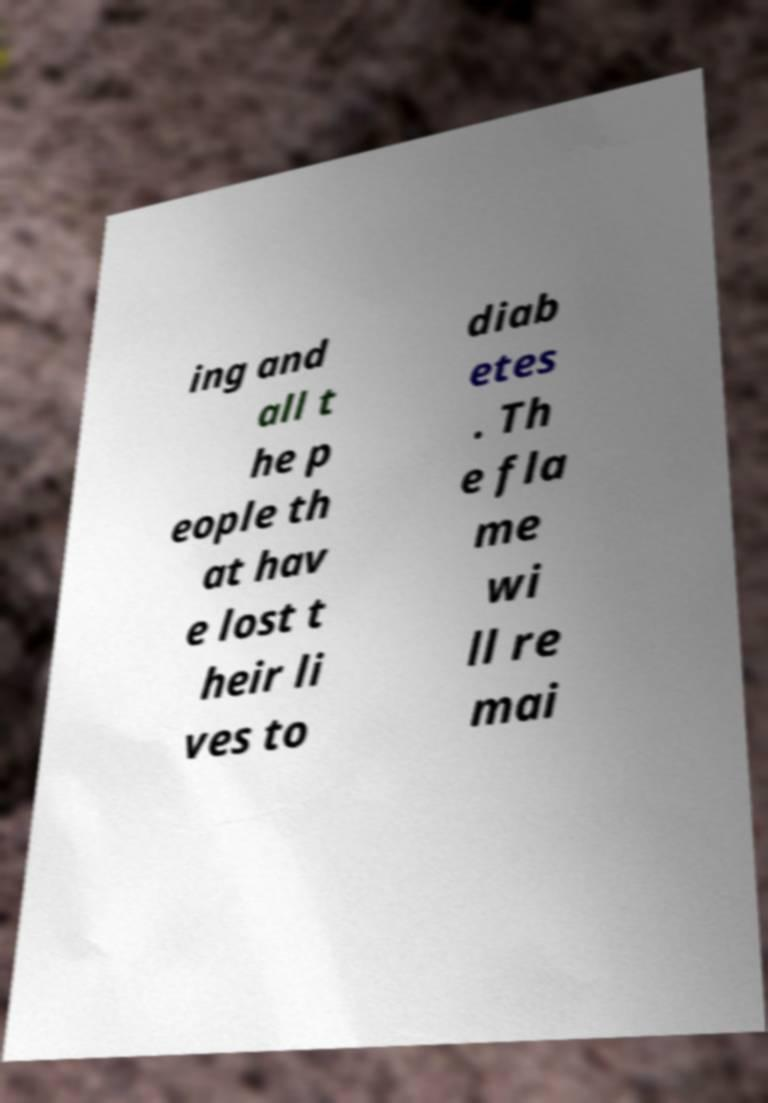Can you read and provide the text displayed in the image?This photo seems to have some interesting text. Can you extract and type it out for me? ing and all t he p eople th at hav e lost t heir li ves to diab etes . Th e fla me wi ll re mai 